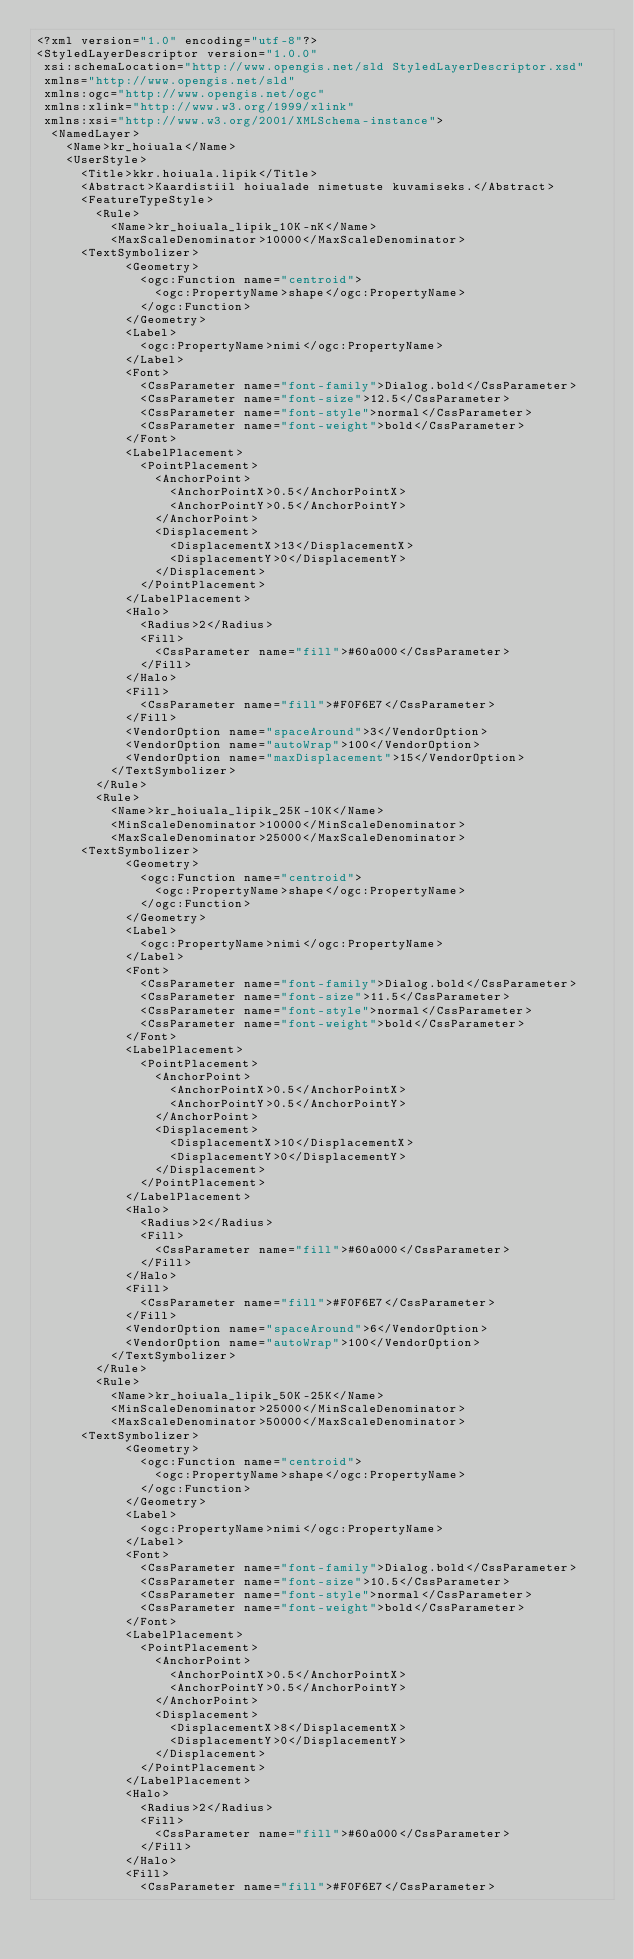<code> <loc_0><loc_0><loc_500><loc_500><_Scheme_><?xml version="1.0" encoding="utf-8"?>
<StyledLayerDescriptor version="1.0.0" 
 xsi:schemaLocation="http://www.opengis.net/sld StyledLayerDescriptor.xsd" 
 xmlns="http://www.opengis.net/sld" 
 xmlns:ogc="http://www.opengis.net/ogc" 
 xmlns:xlink="http://www.w3.org/1999/xlink" 
 xmlns:xsi="http://www.w3.org/2001/XMLSchema-instance">
  <NamedLayer>
    <Name>kr_hoiuala</Name>
    <UserStyle>
      <Title>kkr.hoiuala.lipik</Title>
      <Abstract>Kaardistiil hoiualade nimetuste kuvamiseks.</Abstract>
      <FeatureTypeStyle>
        <Rule>
          <Name>kr_hoiuala_lipik_10K-nK</Name>
          <MaxScaleDenominator>10000</MaxScaleDenominator>
		  <TextSymbolizer>
            <Geometry>
              <ogc:Function name="centroid">
                <ogc:PropertyName>shape</ogc:PropertyName>
              </ogc:Function>
            </Geometry>
            <Label>
              <ogc:PropertyName>nimi</ogc:PropertyName>
            </Label>
            <Font>
              <CssParameter name="font-family">Dialog.bold</CssParameter>
              <CssParameter name="font-size">12.5</CssParameter>
              <CssParameter name="font-style">normal</CssParameter>
              <CssParameter name="font-weight">bold</CssParameter>
            </Font>
            <LabelPlacement>
              <PointPlacement>
              	<AnchorPoint>
                  <AnchorPointX>0.5</AnchorPointX>
                  <AnchorPointY>0.5</AnchorPointY>
                </AnchorPoint>
                <Displacement>
                  <DisplacementX>13</DisplacementX>
                  <DisplacementY>0</DisplacementY>
                </Displacement>
              </PointPlacement>
            </LabelPlacement>
            <Halo>
              <Radius>2</Radius>
              <Fill>
                <CssParameter name="fill">#60a000</CssParameter>
              </Fill> 
            </Halo>
            <Fill>
              <CssParameter name="fill">#F0F6E7</CssParameter>
            </Fill>
            <VendorOption name="spaceAround">3</VendorOption>
            <VendorOption name="autoWrap">100</VendorOption>
            <VendorOption name="maxDisplacement">15</VendorOption>
          </TextSymbolizer>
        </Rule>
        <Rule>
          <Name>kr_hoiuala_lipik_25K-10K</Name>
          <MinScaleDenominator>10000</MinScaleDenominator>
          <MaxScaleDenominator>25000</MaxScaleDenominator>
		  <TextSymbolizer>
            <Geometry>
              <ogc:Function name="centroid">
                <ogc:PropertyName>shape</ogc:PropertyName>
              </ogc:Function>
            </Geometry>
            <Label>
              <ogc:PropertyName>nimi</ogc:PropertyName>
            </Label>
            <Font>
              <CssParameter name="font-family">Dialog.bold</CssParameter>
              <CssParameter name="font-size">11.5</CssParameter>
              <CssParameter name="font-style">normal</CssParameter>
              <CssParameter name="font-weight">bold</CssParameter>
            </Font>
            <LabelPlacement>
              <PointPlacement>
              	<AnchorPoint>
                  <AnchorPointX>0.5</AnchorPointX>
                  <AnchorPointY>0.5</AnchorPointY>
                </AnchorPoint>
                <Displacement>
                  <DisplacementX>10</DisplacementX>
                  <DisplacementY>0</DisplacementY>
                </Displacement>
              </PointPlacement>
            </LabelPlacement>
            <Halo>
              <Radius>2</Radius>
              <Fill>
                <CssParameter name="fill">#60a000</CssParameter>
              </Fill> 
            </Halo>
            <Fill>
              <CssParameter name="fill">#F0F6E7</CssParameter>
            </Fill>
            <VendorOption name="spaceAround">6</VendorOption>
            <VendorOption name="autoWrap">100</VendorOption>
          </TextSymbolizer>
        </Rule>
        <Rule>
          <Name>kr_hoiuala_lipik_50K-25K</Name>
          <MinScaleDenominator>25000</MinScaleDenominator>
          <MaxScaleDenominator>50000</MaxScaleDenominator>
		  <TextSymbolizer>
            <Geometry>
              <ogc:Function name="centroid">
                <ogc:PropertyName>shape</ogc:PropertyName>
              </ogc:Function>
            </Geometry>
            <Label>
              <ogc:PropertyName>nimi</ogc:PropertyName>
            </Label>
            <Font>
              <CssParameter name="font-family">Dialog.bold</CssParameter>
              <CssParameter name="font-size">10.5</CssParameter>
              <CssParameter name="font-style">normal</CssParameter>
              <CssParameter name="font-weight">bold</CssParameter>
            </Font>
            <LabelPlacement>
              <PointPlacement>
              	<AnchorPoint>
                  <AnchorPointX>0.5</AnchorPointX>
                  <AnchorPointY>0.5</AnchorPointY>
                </AnchorPoint>
                <Displacement>
                  <DisplacementX>8</DisplacementX>
                  <DisplacementY>0</DisplacementY>
                </Displacement>
              </PointPlacement>
            </LabelPlacement>
            <Halo>
              <Radius>2</Radius>
              <Fill>
                <CssParameter name="fill">#60a000</CssParameter>
              </Fill> 
            </Halo>
            <Fill>
              <CssParameter name="fill">#F0F6E7</CssParameter></code> 